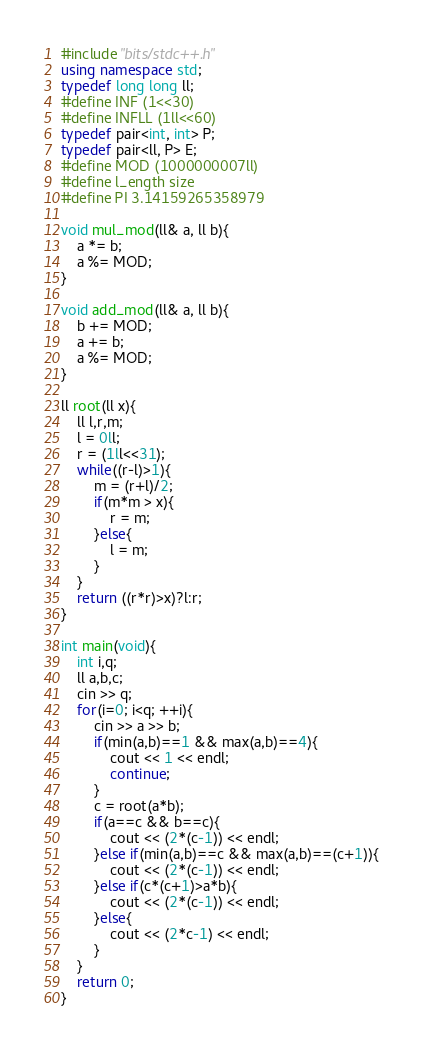<code> <loc_0><loc_0><loc_500><loc_500><_C++_>#include "bits/stdc++.h"
using namespace std;
typedef long long ll;
#define INF (1<<30)
#define INFLL (1ll<<60)
typedef pair<int, int> P;
typedef pair<ll, P> E;
#define MOD (1000000007ll)
#define l_ength size
#define PI 3.14159265358979

void mul_mod(ll& a, ll b){
	a *= b;
	a %= MOD;
}

void add_mod(ll& a, ll b){
	b += MOD;
	a += b;
	a %= MOD;
}

ll root(ll x){
	ll l,r,m;
	l = 0ll;
	r = (1ll<<31);
	while((r-l)>1){
		m = (r+l)/2;
		if(m*m > x){
			r = m;
		}else{
			l = m;
		}
	}
	return ((r*r)>x)?l:r;
}

int main(void){
	int i,q;
	ll a,b,c;
	cin >> q;
	for(i=0; i<q; ++i){
		cin >> a >> b;
		if(min(a,b)==1 && max(a,b)==4){
			cout << 1 << endl;
			continue;
		}
		c = root(a*b);
		if(a==c && b==c){
			cout << (2*(c-1)) << endl;
		}else if(min(a,b)==c && max(a,b)==(c+1)){
			cout << (2*(c-1)) << endl;
		}else if(c*(c+1)>a*b){
			cout << (2*(c-1)) << endl;
		}else{
			cout << (2*c-1) << endl;
		}
	}
	return 0;
}
</code> 